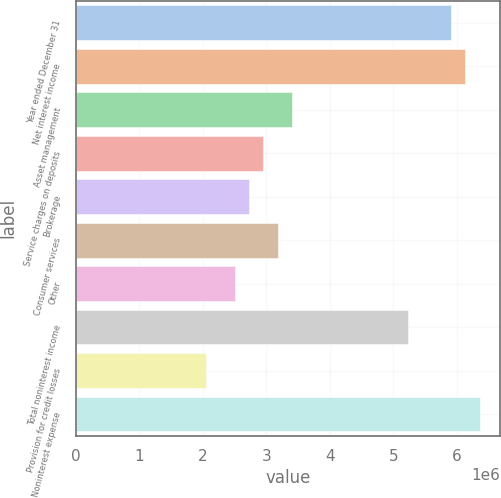Convert chart. <chart><loc_0><loc_0><loc_500><loc_500><bar_chart><fcel>Year ended December 31<fcel>Net interest income<fcel>Asset management<fcel>Service charges on deposits<fcel>Brokerage<fcel>Consumer services<fcel>Other<fcel>Total noninterest income<fcel>Provision for credit losses<fcel>Noninterest expense<nl><fcel>5.9072e+06<fcel>6.1344e+06<fcel>3.408e+06<fcel>2.9536e+06<fcel>2.7264e+06<fcel>3.1808e+06<fcel>2.4992e+06<fcel>5.2256e+06<fcel>2.0448e+06<fcel>6.3616e+06<nl></chart> 